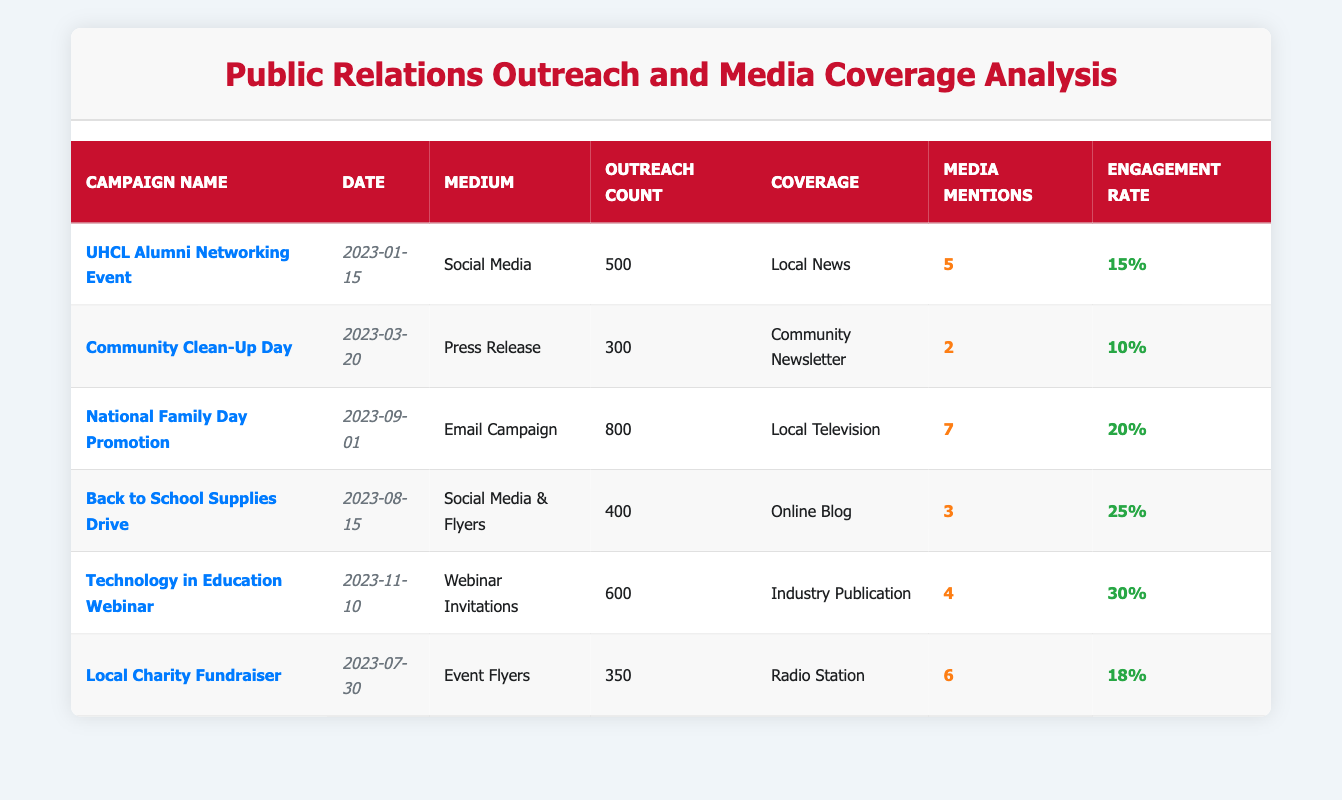What is the outreach count for the "UHCL Alumni Networking Event"? The table indicates that the outreach count for the "UHCL Alumni Networking Event" campaign is listed directly in the corresponding row under the "Outreach Count" column. The value is 500.
Answer: 500 How many media mentions did the "National Family Day Promotion" receive? Referring to the row for the "National Family Day Promotion," the "Media Mentions" column shows the number of times the campaign was mentioned in media, which is 7.
Answer: 7 What was the engagement rate for the "Back to School Supplies Drive"? The engagement rate for the "Back to School Supplies Drive" is provided in the row where this campaign is listed under the "Engagement Rate" column, showing a rate of 25%.
Answer: 25% Which campaign had the highest outreach count? To find out which campaign had the highest outreach count, I need to look at the "Outreach Count" values across all campaigns. The maximum value is 800 for the "National Family Day Promotion."
Answer: National Family Day Promotion What is the average engagement rate of all campaigns listed? First, I sum all the engagement rates: 15% + 10% + 20% + 25% + 30% + 18% = 118%. Then, I divide by 6 campaigns to calculate the average: 118% / 6 = 19.67%.
Answer: 19.67% Did the "Community Clean-Up Day" receive more or less media mentions than the "Local Charity Fundraiser"? The "Community Clean-Up Day" received 2 media mentions while the "Local Charity Fundraiser" received 6 media mentions. Since 2 is less than 6, the answer is that it received less media mentions.
Answer: Less Which campaign had the highest engagement rate and what was that rate? I need to look through the engagement rates for all campaigns. The highest engagement rate listed is 30% for the "Technology in Education Webinar."
Answer: Technology in Education Webinar, 30% What is the total outreach count for all campaigns combined? I will sum the outreach counts: 500 + 300 + 800 + 400 + 600 + 350 = 2950. This gives the total outreach count for all campaigns combined.
Answer: 2950 Is the outreach count of the "Technology in Education Webinar" higher than that of the "Local Charity Fundraiser"? The outreach count for the "Technology in Education Webinar" is 600, while the "Local Charity Fundraiser" has an outreach count of 350. Since 600 is higher than 350, the statement is true.
Answer: Yes What is the total number of media mentions across all campaigns? To find this, I will add all the media mentions together: 5 + 2 + 7 + 3 + 4 + 6 = 27. Therefore, the total number of media mentions across all campaigns is 27.
Answer: 27 